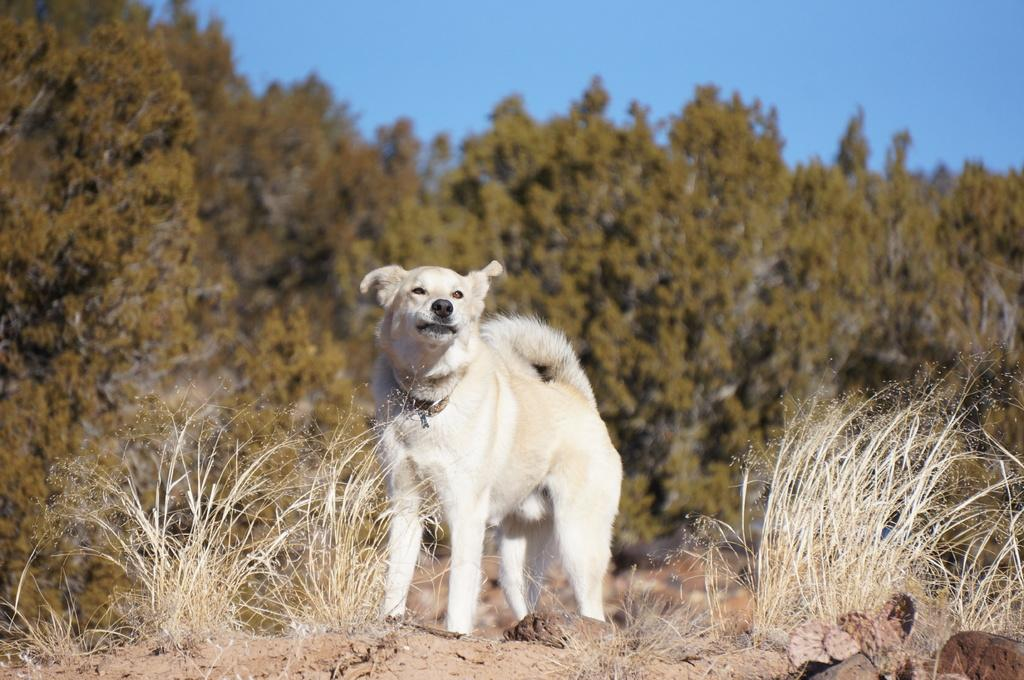What animal can be seen in the image? There is a dog in the image. What is the dog doing in the image? The dog is standing on the ground. What type of terrain is visible in the image? Grass is present in the image. What can be seen in the background of the image? There are trees in the background of the image. What is visible at the top of the image? The sky is visible at the top of the image. When was the image taken? The image was taken during the day. What type of wax can be seen melting in the image? There is no wax present in the image; it features a dog standing on the ground. What type of ray is visible in the image? There is no ray visible in the image; it features a dog standing on the ground. 